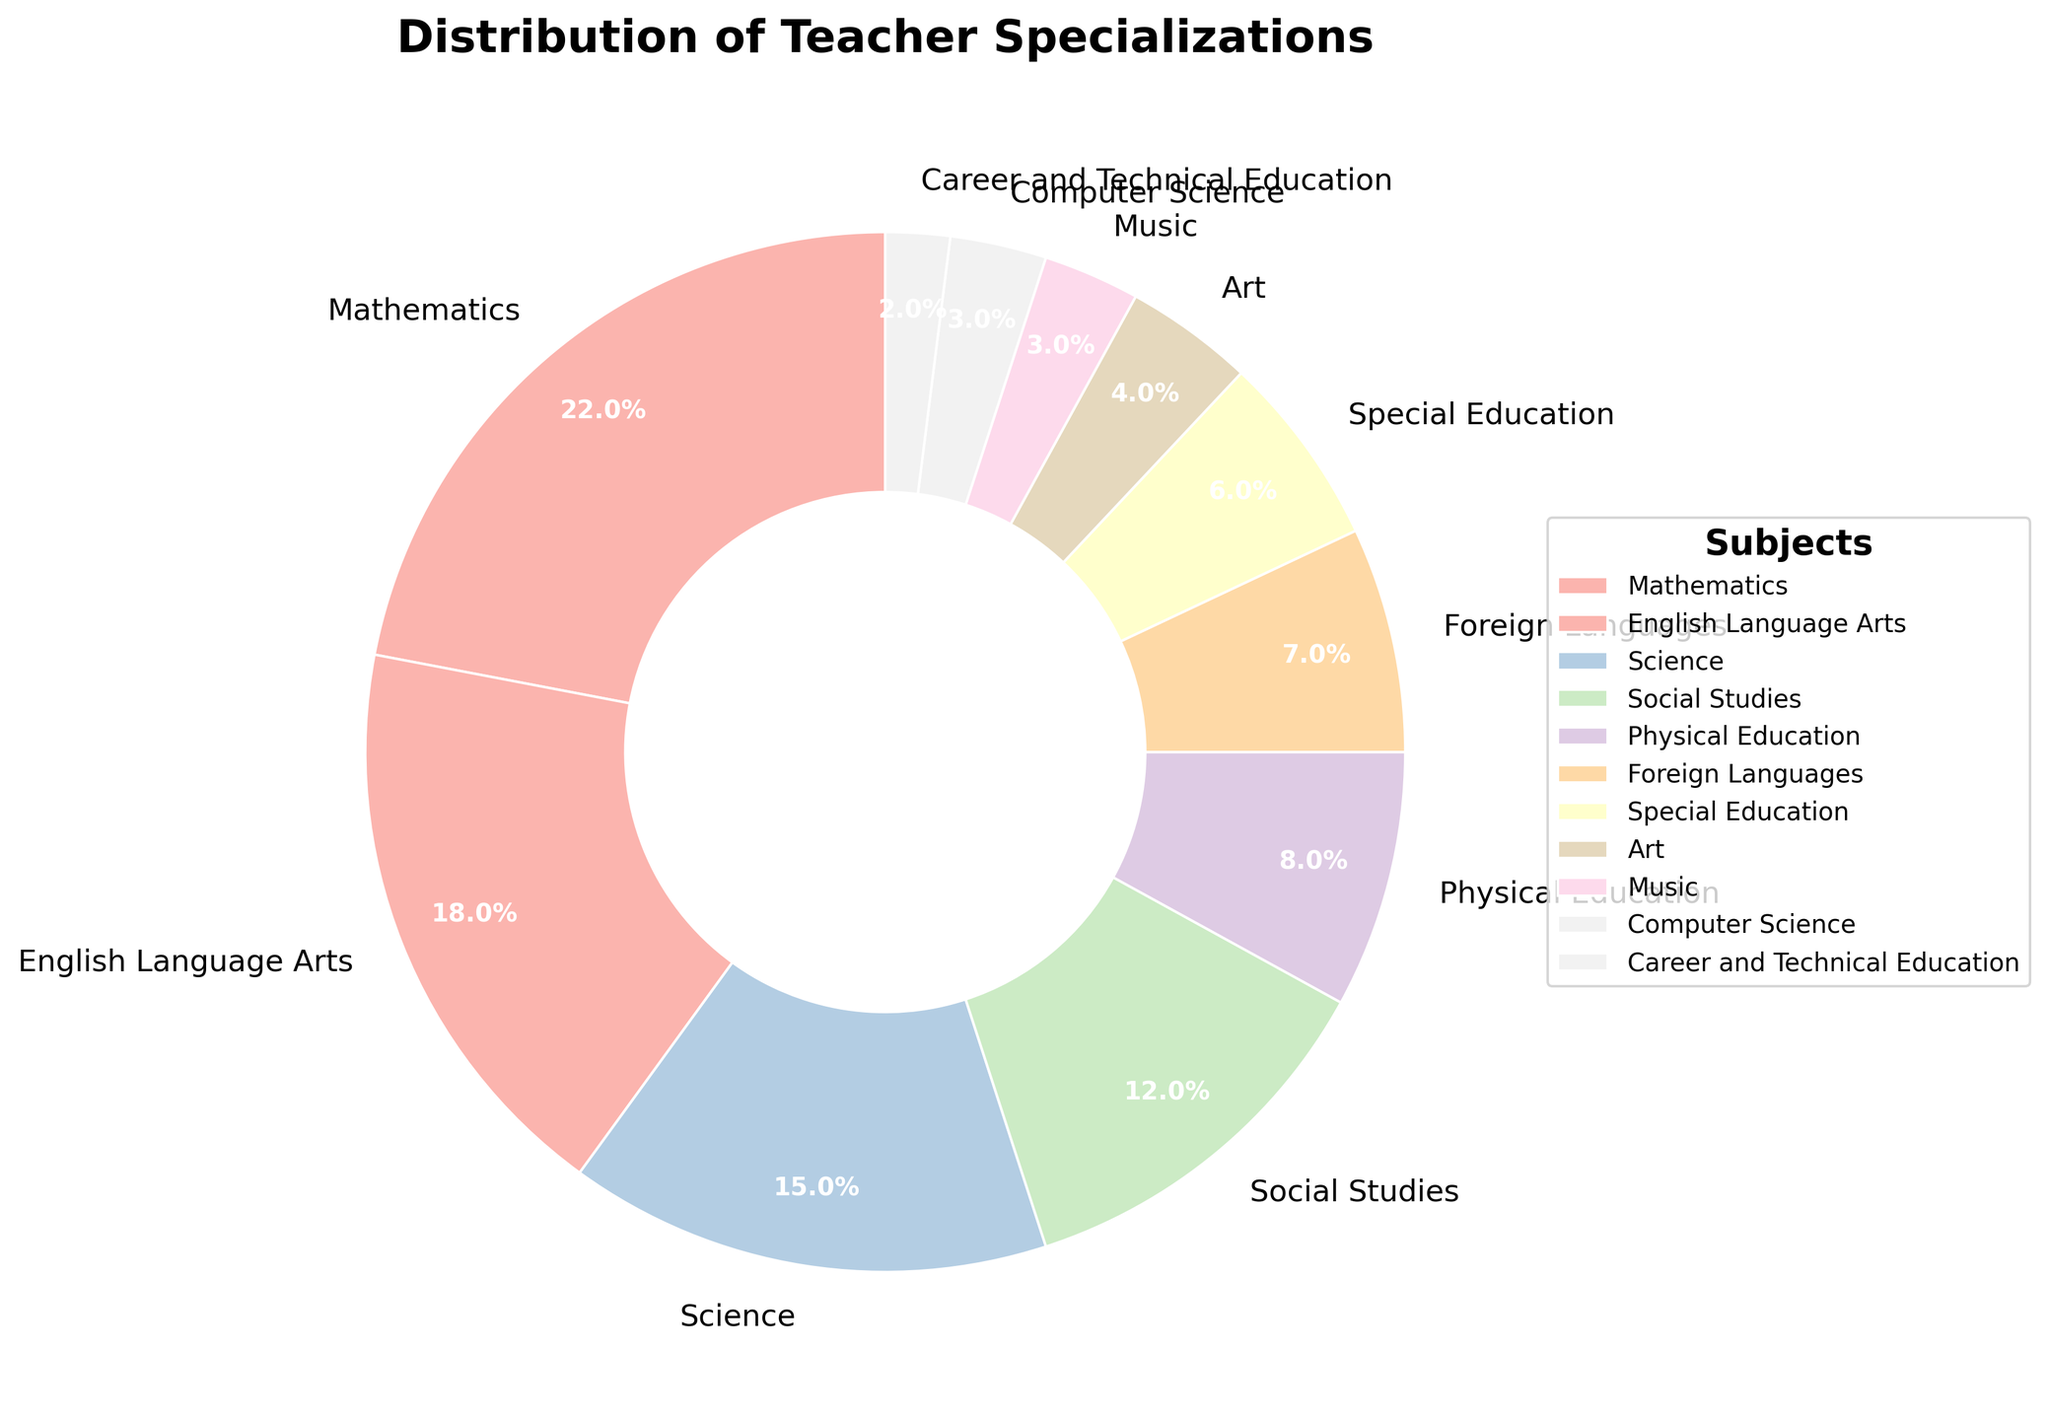Which subject has the highest percentage of teachers? Review the pie chart segments and look for the largest one. The Mathematics segment is the largest at 22%.
Answer: Mathematics Which subject has the second-lowest percentage of teachers? Examine the pie chart for the second-smallest segment. The Music segment appears right before Computer Science, which is the smallest. Music is 3%.
Answer: Music What is the sum of the percentages of Mathematics and Science teachers? Locate the segments for Mathematics and Science. Mathematics is 22% and Science is 15%. Summing them up gives 22 + 15 = 37%.
Answer: 37% How does the percentage of Physical Education teachers compare to that of Foreign Languages teachers? Identify the segments for Physical Education and Foreign Languages. Physical Education is 8% and Foreign Languages is 7%. Comparing them shows that Physical Education has a higher percentage.
Answer: Physical Education has a higher percentage What is the total percentage of teachers in Art, Music, and Computer Science combined? Find the percentages for Art, Music, and Computer Science. They are 4%, 3%, and 3% respectively. Adding them gives 4 + 3 + 3 = 10%.
Answer: 10% Which subject has a larger segment, Social Studies or Special Education? Find and compare the segments for Social Studies and Special Education. Social Studies is 12% and Special Education is 6%. Social Studies is larger.
Answer: Social Studies Are there more teachers in Career and Technical Education or Foreign Languages? Locate the segments for Career and Technical Education and Foreign Languages. Career and Technical Education is 2% and Foreign Languages is 7%. Foreign Languages has more teachers.
Answer: Foreign Languages What percentage of teachers are in subjects other than Mathematics, English Language Arts, and Science combined? Find the percentages for Mathematics, English Language Arts, and Science and subtract from 100%. Their percentages are 22%, 18%, and 15% respectively. Total is 22 + 18 + 15 = 55%. Subtract from 100 to get 100 - 55 = 45%.
Answer: 45% Is the percentage of teachers in Physical Education closer to that in Social Studies or Foreign Languages? Compare Physical Education (8%) with Social Studies (12%) and Foreign Languages (7%). Physical Education (8%) is closer to Foreign Languages (7%).
Answer: Foreign Languages What's the difference in percentage points between the subject with the highest and the subject with the lowest percentage of teachers? Identify the highest (Mathematics, 22%) and the lowest (Career and Technical Education, 2%). Subtract to find the difference: 22 - 2 = 20%.
Answer: 20% 